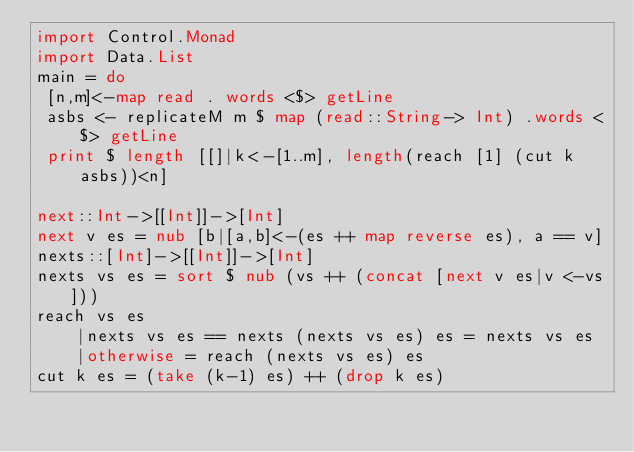<code> <loc_0><loc_0><loc_500><loc_500><_Haskell_>import Control.Monad
import Data.List
main = do
 [n,m]<-map read . words <$> getLine
 asbs <- replicateM m $ map (read::String-> Int) .words <$> getLine
 print $ length [[]|k<-[1..m], length(reach [1] (cut k asbs))<n]
 
next::Int->[[Int]]->[Int]
next v es = nub [b|[a,b]<-(es ++ map reverse es), a == v]
nexts::[Int]->[[Int]]->[Int]
nexts vs es = sort $ nub (vs ++ (concat [next v es|v <-vs]))
reach vs es
	|nexts vs es == nexts (nexts vs es) es = nexts vs es
    |otherwise = reach (nexts vs es) es
cut k es = (take (k-1) es) ++ (drop k es) 
</code> 